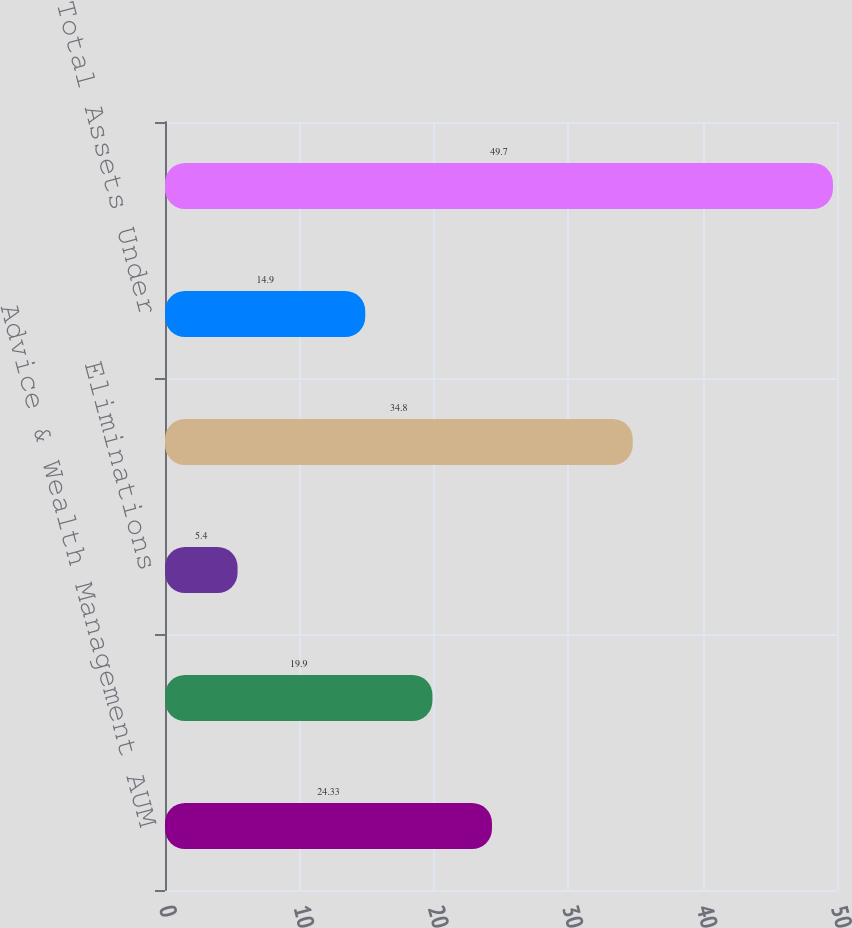Convert chart. <chart><loc_0><loc_0><loc_500><loc_500><bar_chart><fcel>Advice & Wealth Management AUM<fcel>Asset Management AUM<fcel>Eliminations<fcel>Total Assets Under Management<fcel>Total Assets Under<fcel>Total AUM and AUA<nl><fcel>24.33<fcel>19.9<fcel>5.4<fcel>34.8<fcel>14.9<fcel>49.7<nl></chart> 